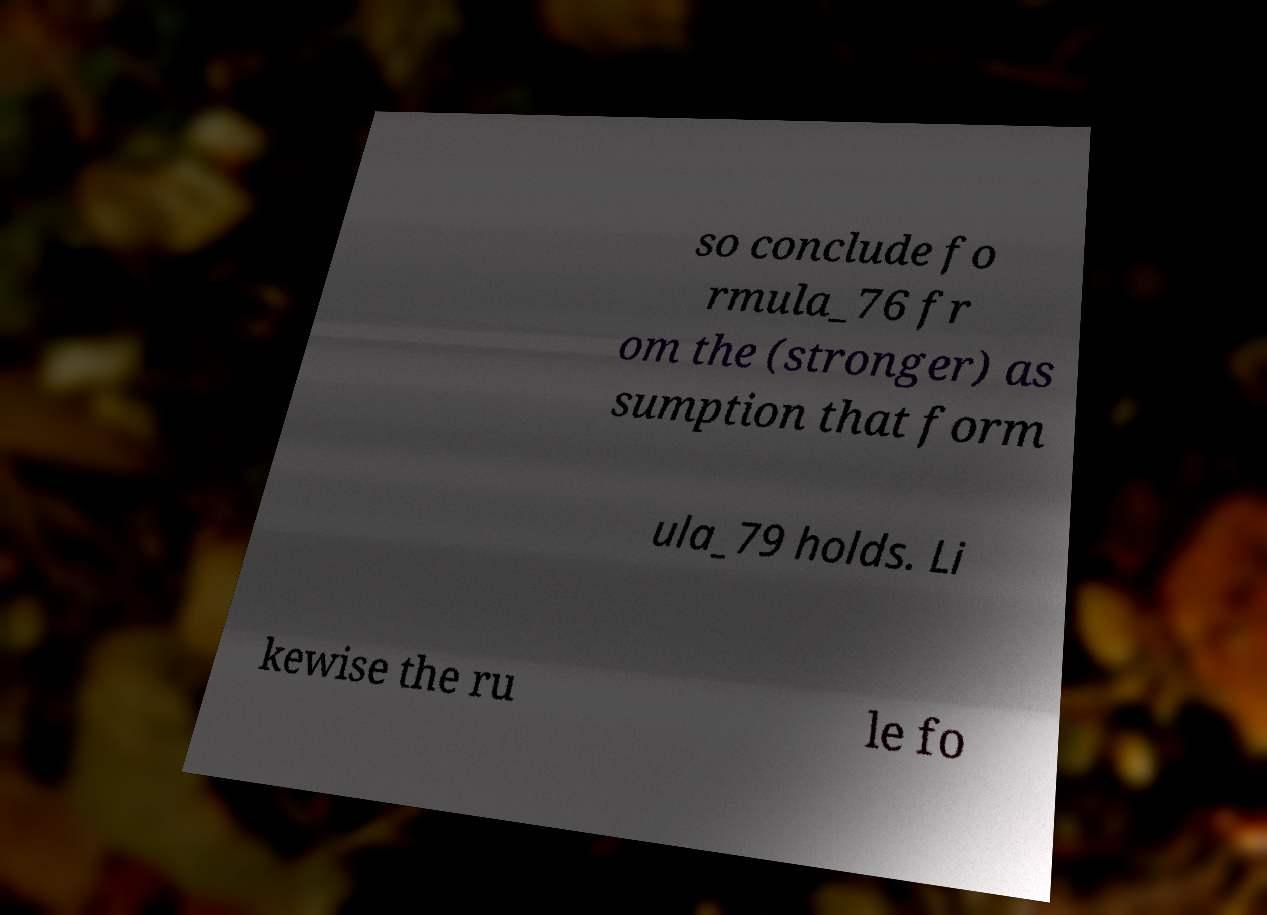Please read and relay the text visible in this image. What does it say? so conclude fo rmula_76 fr om the (stronger) as sumption that form ula_79 holds. Li kewise the ru le fo 